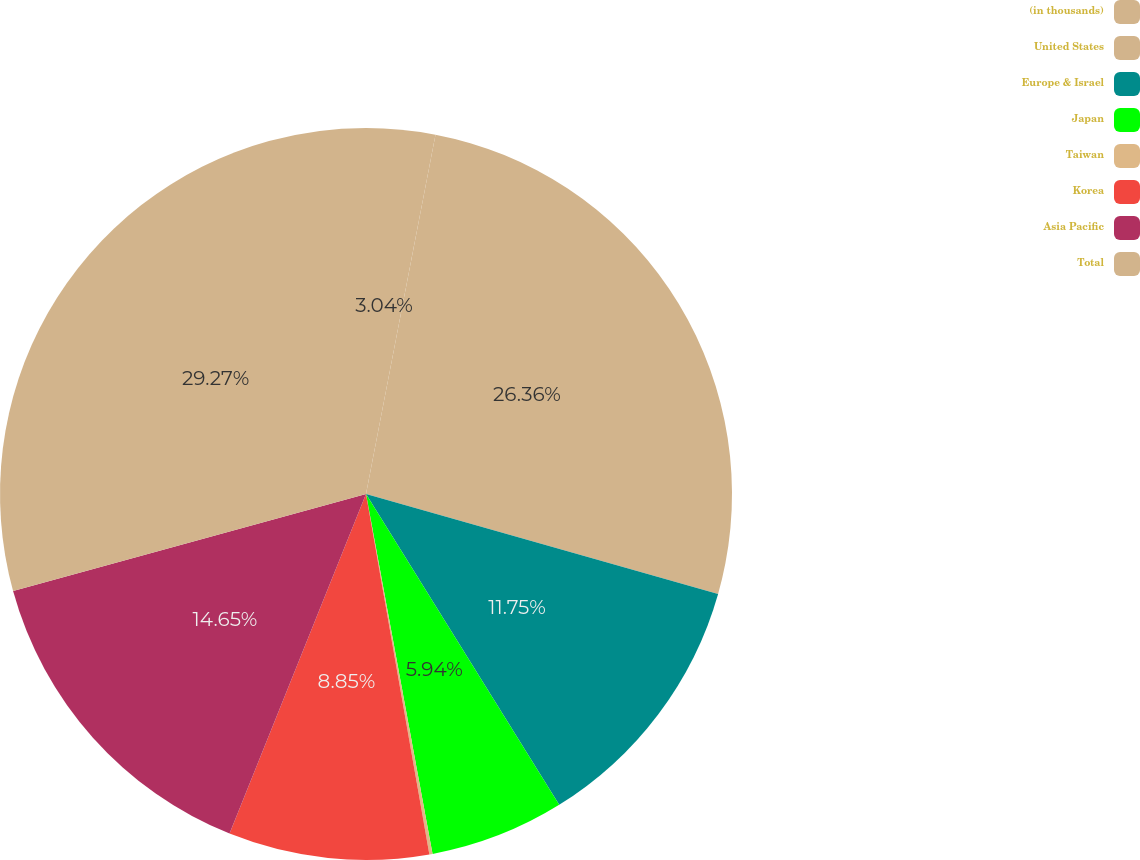<chart> <loc_0><loc_0><loc_500><loc_500><pie_chart><fcel>(in thousands)<fcel>United States<fcel>Europe & Israel<fcel>Japan<fcel>Taiwan<fcel>Korea<fcel>Asia Pacific<fcel>Total<nl><fcel>3.04%<fcel>26.36%<fcel>11.75%<fcel>5.94%<fcel>0.14%<fcel>8.85%<fcel>14.65%<fcel>29.27%<nl></chart> 